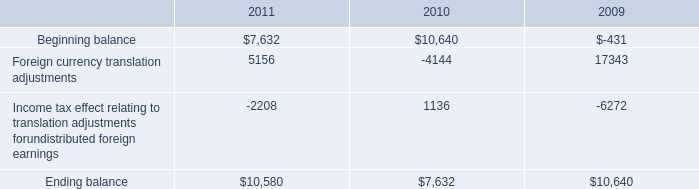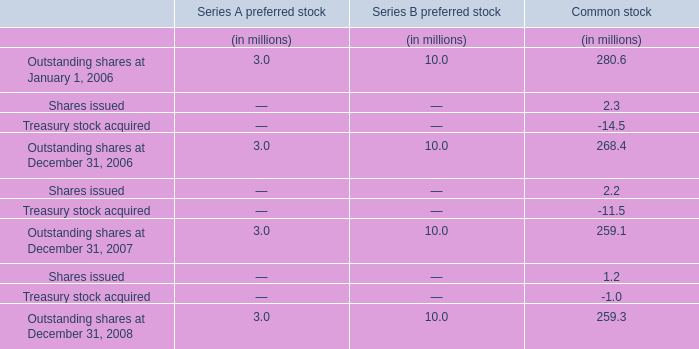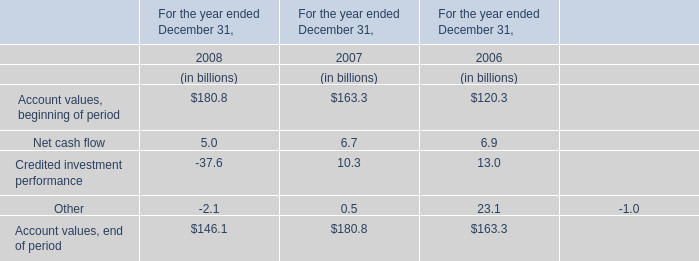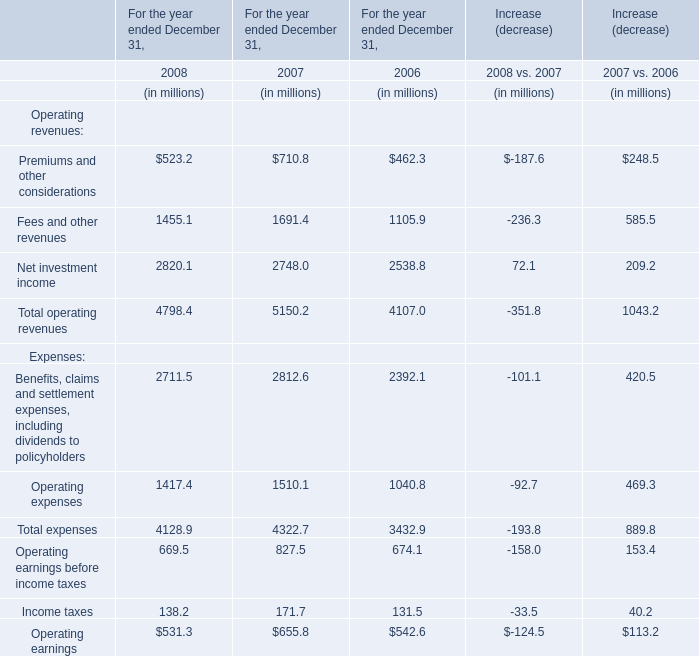Which year has the greatest proportion of net investment income? 
Answer: 2006. 